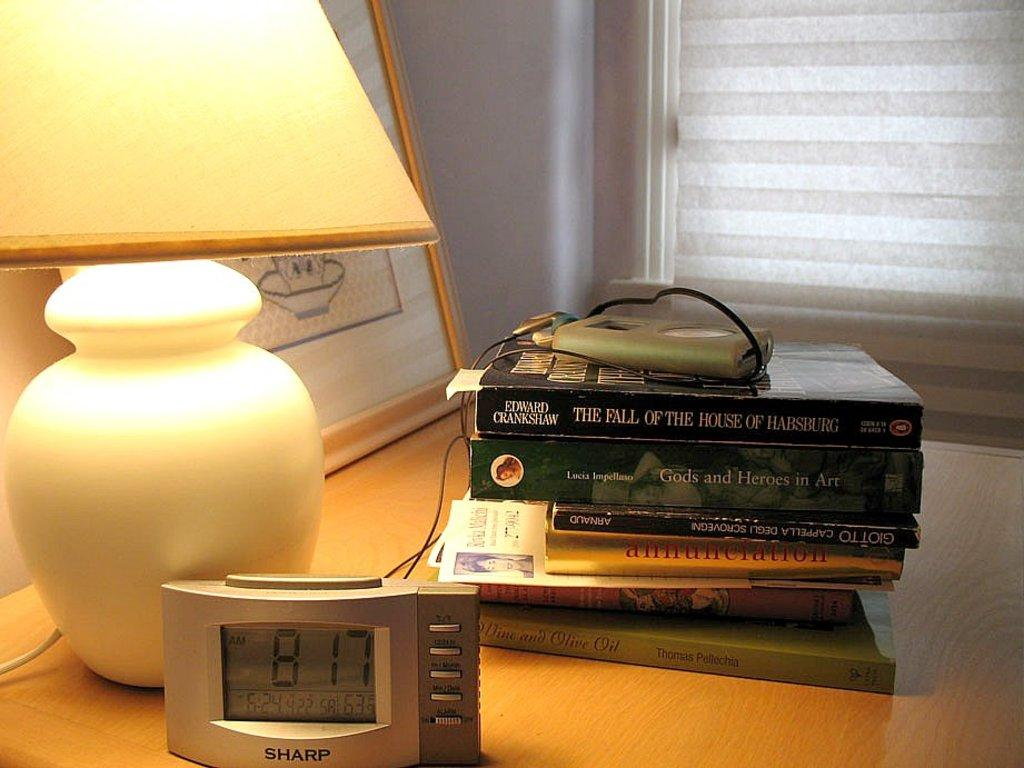<image>
Relay a brief, clear account of the picture shown. A nightside table with a Sharp clock, books, and a lamp 